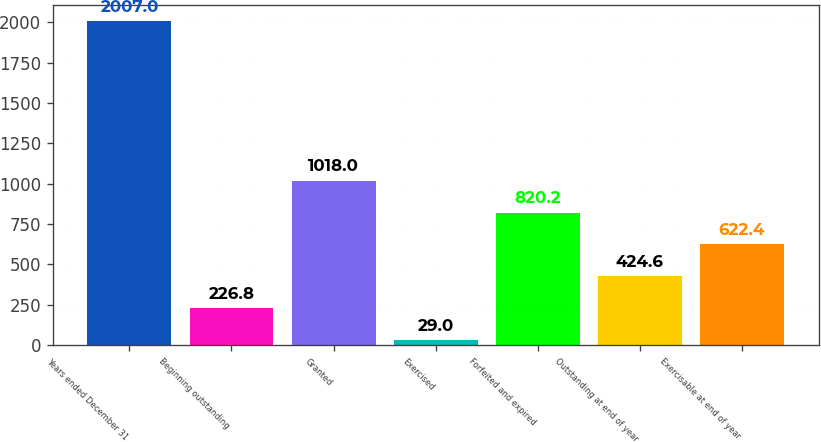Convert chart. <chart><loc_0><loc_0><loc_500><loc_500><bar_chart><fcel>Years ended December 31<fcel>Beginning outstanding<fcel>Granted<fcel>Exercised<fcel>Forfeited and expired<fcel>Outstanding at end of year<fcel>Exercisable at end of year<nl><fcel>2007<fcel>226.8<fcel>1018<fcel>29<fcel>820.2<fcel>424.6<fcel>622.4<nl></chart> 